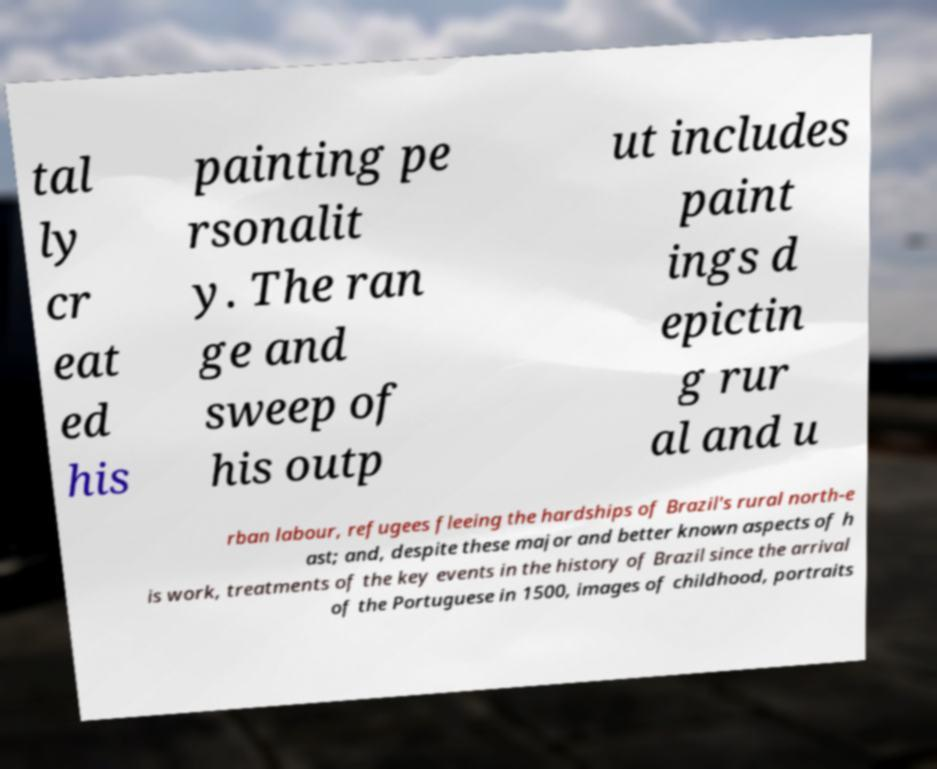Please identify and transcribe the text found in this image. tal ly cr eat ed his painting pe rsonalit y. The ran ge and sweep of his outp ut includes paint ings d epictin g rur al and u rban labour, refugees fleeing the hardships of Brazil's rural north-e ast; and, despite these major and better known aspects of h is work, treatments of the key events in the history of Brazil since the arrival of the Portuguese in 1500, images of childhood, portraits 